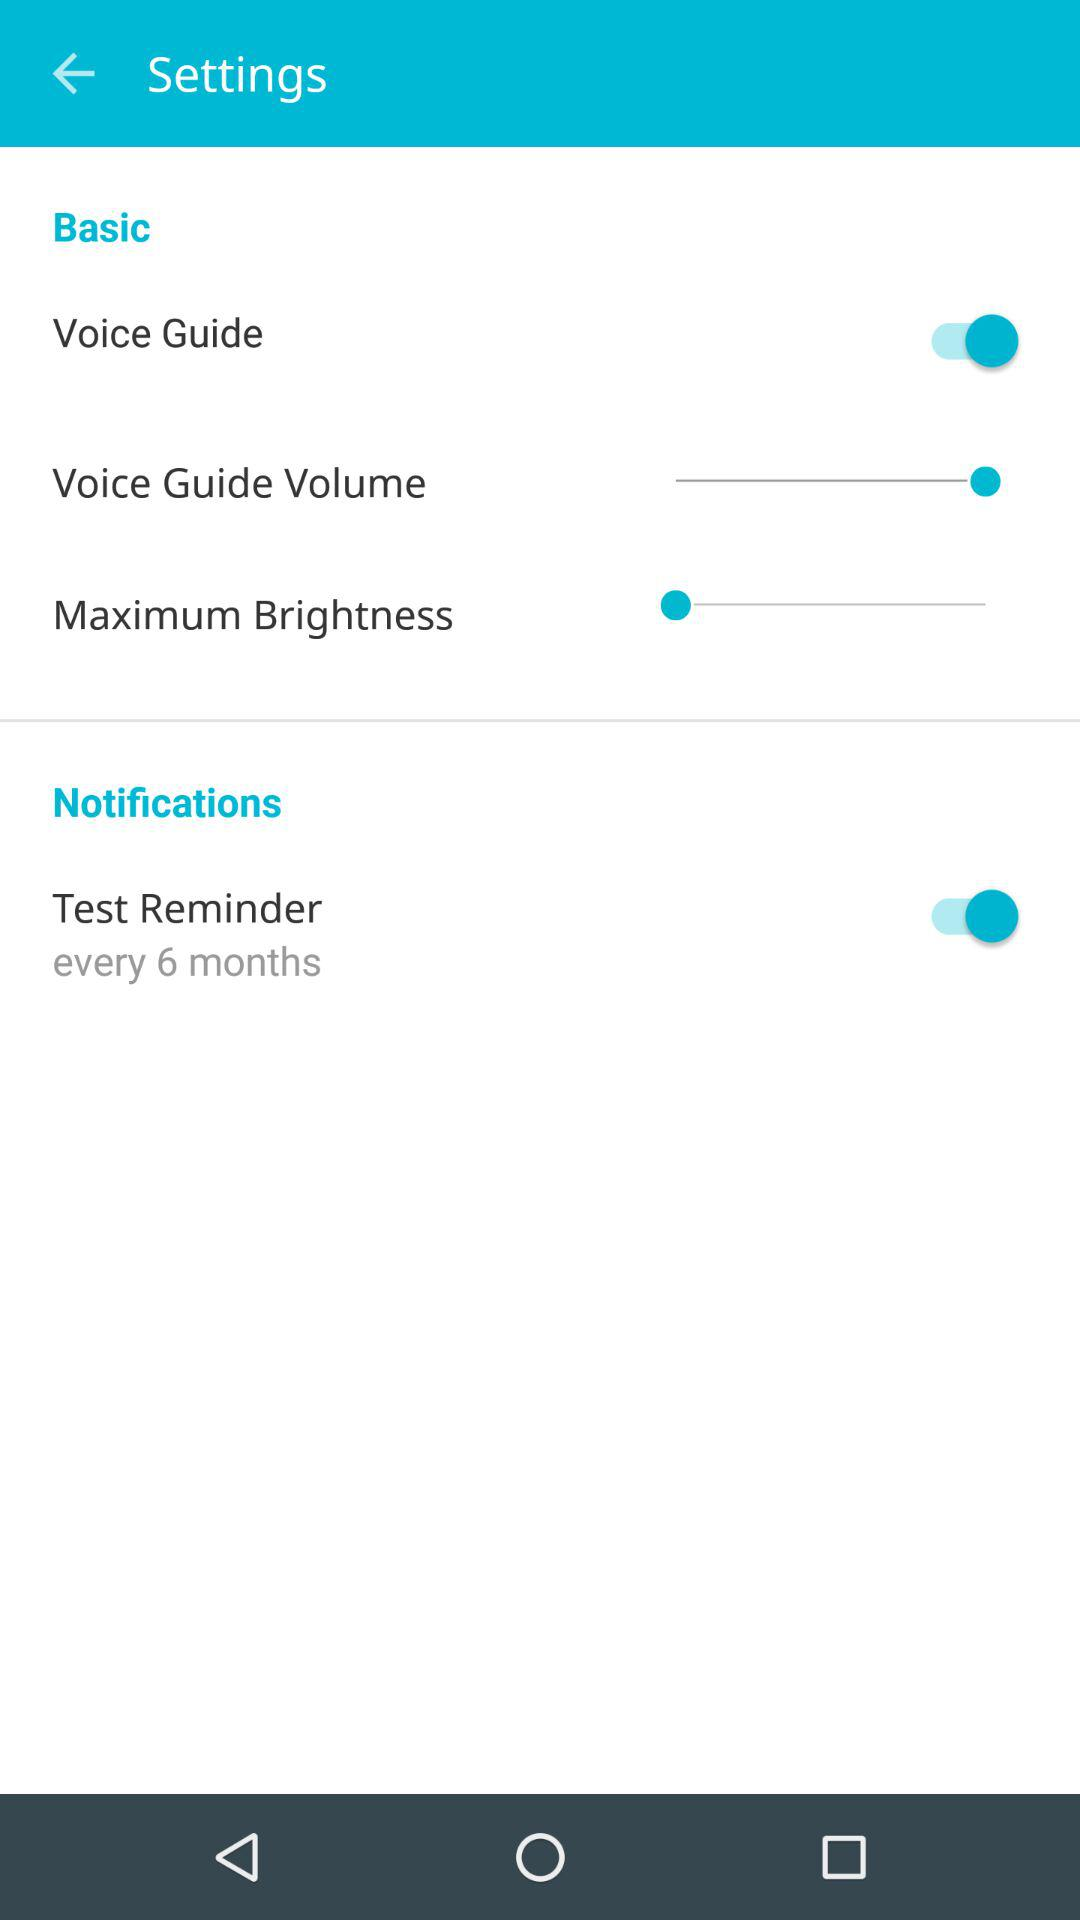What is the status of "Voice Guide"? The status is "on". 